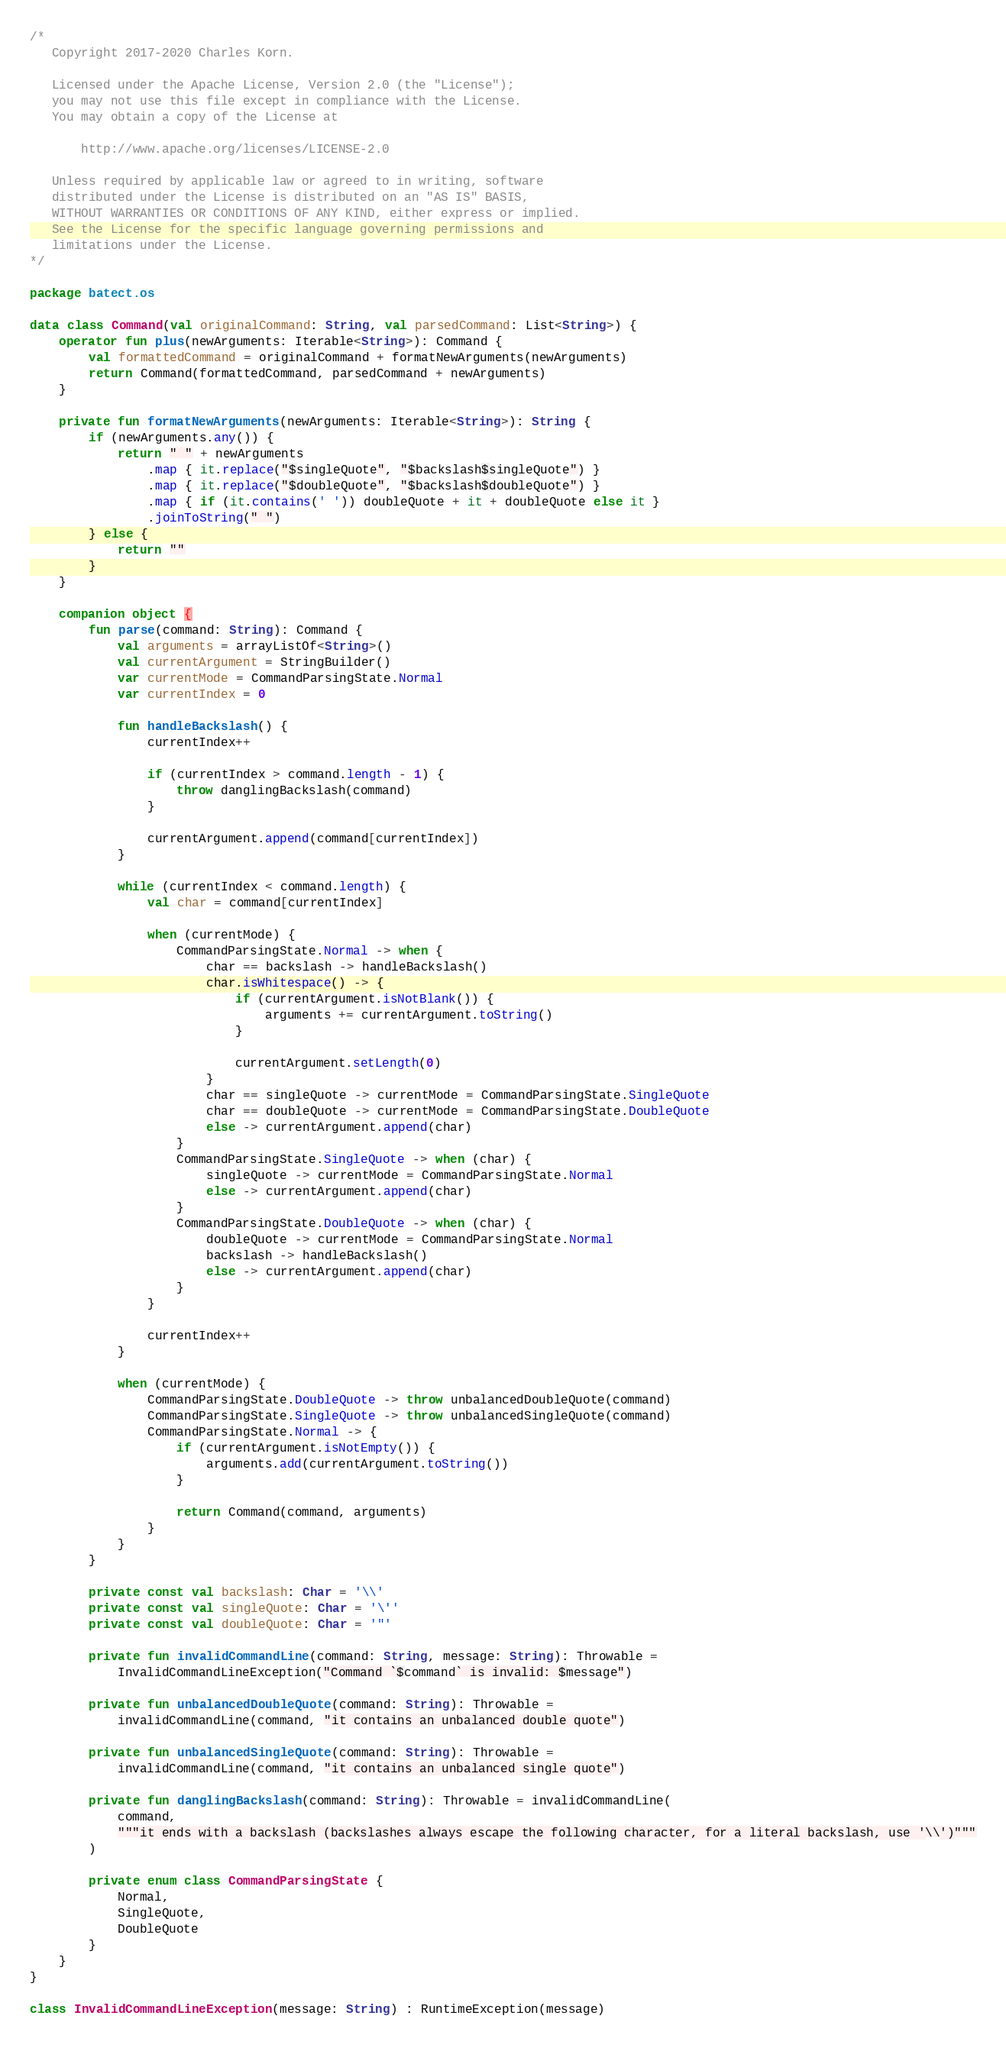Convert code to text. <code><loc_0><loc_0><loc_500><loc_500><_Kotlin_>/*
   Copyright 2017-2020 Charles Korn.

   Licensed under the Apache License, Version 2.0 (the "License");
   you may not use this file except in compliance with the License.
   You may obtain a copy of the License at

       http://www.apache.org/licenses/LICENSE-2.0

   Unless required by applicable law or agreed to in writing, software
   distributed under the License is distributed on an "AS IS" BASIS,
   WITHOUT WARRANTIES OR CONDITIONS OF ANY KIND, either express or implied.
   See the License for the specific language governing permissions and
   limitations under the License.
*/

package batect.os

data class Command(val originalCommand: String, val parsedCommand: List<String>) {
    operator fun plus(newArguments: Iterable<String>): Command {
        val formattedCommand = originalCommand + formatNewArguments(newArguments)
        return Command(formattedCommand, parsedCommand + newArguments)
    }

    private fun formatNewArguments(newArguments: Iterable<String>): String {
        if (newArguments.any()) {
            return " " + newArguments
                .map { it.replace("$singleQuote", "$backslash$singleQuote") }
                .map { it.replace("$doubleQuote", "$backslash$doubleQuote") }
                .map { if (it.contains(' ')) doubleQuote + it + doubleQuote else it }
                .joinToString(" ")
        } else {
            return ""
        }
    }

    companion object {
        fun parse(command: String): Command {
            val arguments = arrayListOf<String>()
            val currentArgument = StringBuilder()
            var currentMode = CommandParsingState.Normal
            var currentIndex = 0

            fun handleBackslash() {
                currentIndex++

                if (currentIndex > command.length - 1) {
                    throw danglingBackslash(command)
                }

                currentArgument.append(command[currentIndex])
            }

            while (currentIndex < command.length) {
                val char = command[currentIndex]

                when (currentMode) {
                    CommandParsingState.Normal -> when {
                        char == backslash -> handleBackslash()
                        char.isWhitespace() -> {
                            if (currentArgument.isNotBlank()) {
                                arguments += currentArgument.toString()
                            }

                            currentArgument.setLength(0)
                        }
                        char == singleQuote -> currentMode = CommandParsingState.SingleQuote
                        char == doubleQuote -> currentMode = CommandParsingState.DoubleQuote
                        else -> currentArgument.append(char)
                    }
                    CommandParsingState.SingleQuote -> when (char) {
                        singleQuote -> currentMode = CommandParsingState.Normal
                        else -> currentArgument.append(char)
                    }
                    CommandParsingState.DoubleQuote -> when (char) {
                        doubleQuote -> currentMode = CommandParsingState.Normal
                        backslash -> handleBackslash()
                        else -> currentArgument.append(char)
                    }
                }

                currentIndex++
            }

            when (currentMode) {
                CommandParsingState.DoubleQuote -> throw unbalancedDoubleQuote(command)
                CommandParsingState.SingleQuote -> throw unbalancedSingleQuote(command)
                CommandParsingState.Normal -> {
                    if (currentArgument.isNotEmpty()) {
                        arguments.add(currentArgument.toString())
                    }

                    return Command(command, arguments)
                }
            }
        }

        private const val backslash: Char = '\\'
        private const val singleQuote: Char = '\''
        private const val doubleQuote: Char = '"'

        private fun invalidCommandLine(command: String, message: String): Throwable =
            InvalidCommandLineException("Command `$command` is invalid: $message")

        private fun unbalancedDoubleQuote(command: String): Throwable =
            invalidCommandLine(command, "it contains an unbalanced double quote")

        private fun unbalancedSingleQuote(command: String): Throwable =
            invalidCommandLine(command, "it contains an unbalanced single quote")

        private fun danglingBackslash(command: String): Throwable = invalidCommandLine(
            command,
            """it ends with a backslash (backslashes always escape the following character, for a literal backslash, use '\\')"""
        )

        private enum class CommandParsingState {
            Normal,
            SingleQuote,
            DoubleQuote
        }
    }
}

class InvalidCommandLineException(message: String) : RuntimeException(message)
</code> 